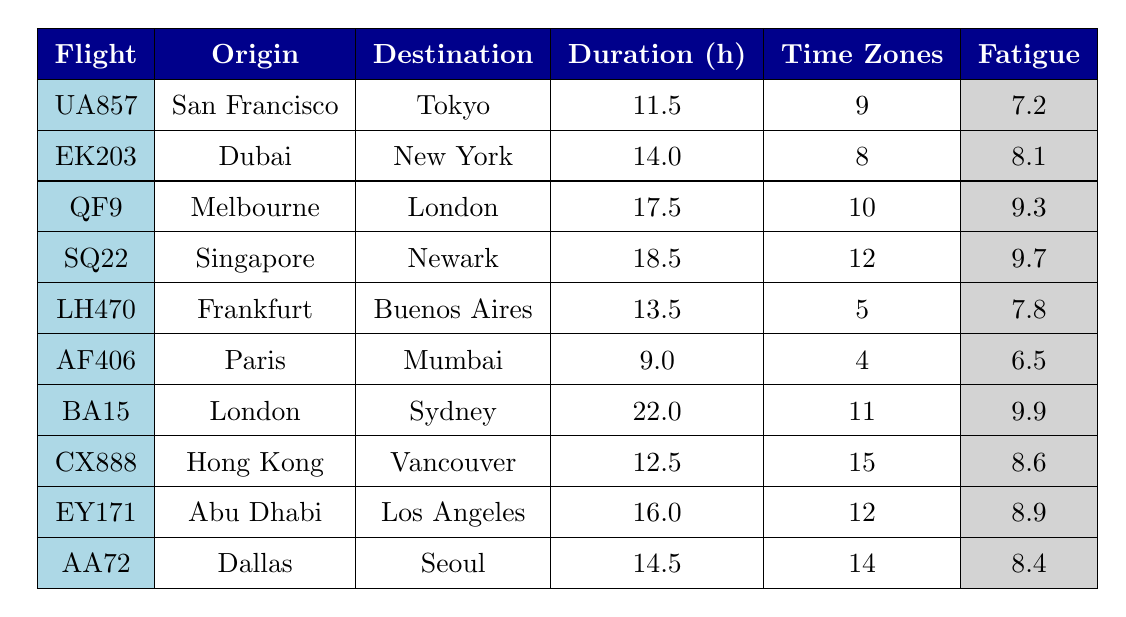What is the average fatigue level for flight EK203? Looking at the table, the average fatigue level is specified for each flight. For flight EK203, the average fatigue level is listed as 8.1.
Answer: 8.1 Which flight has the longest duration? By inspecting the duration column, we see that flight BA15 has the longest duration at 22 hours, compared to the other flights listed.
Answer: BA15 How many time zones does flight SQ22 cross? The table indicates the number of time zones crossed for each flight. Flight SQ22 crosses 12 time zones, according to the respective column.
Answer: 12 What is the fatigue level for the flight with the longest duration? From the analysis of the table, flight BA15 has the longest duration of 22 hours, and its average fatigue level is 9.9.
Answer: 9.9 Which flight has the highest average fatigue level? Examining the average fatigue levels in the table, flight BA15 has the highest average fatigue level at 9.9, more than any other flight.
Answer: BA15 Are there any flights that crossed fewer than 5 time zones? By reviewing the time zones crossed for each flight, we find that flights AF406 and LH470 crossed 4 and 5 time zones respectively. The answer is yes, as AF406 crosses fewer than 5.
Answer: Yes What is the average duration of flights that crossed 10 or more time zones? We identify the flights that crossed 10 or more time zones: QF9 (17.5 hours), SQ22 (18.5 hours), CX888 (12.5 hours), EY171 (16 hours), and AA72 (14.5 hours). Their total duration is (17.5 + 18.5 + 12.5 + 16 + 14.5) = 79 hours. With 5 flights, the average duration is 79/5 = 15.8 hours.
Answer: 15.8 What is the difference in average fatigue level between the shortest and longest flight durations? The shortest flight duration is AF406 at 9 hours with a fatigue level of 6.5. The longest is BA15 at 22 hours with a fatigue level of 9.9. The difference in fatigue is 9.9 - 6.5 = 3.4.
Answer: 3.4 How many flights have an average fatigue level of 8.5 or above? Upon reviewing the fatigue levels, the flights with fatigue levels of 8.5 or above are EK203 (8.1), QF9 (9.3), SQ22 (9.7), BA15 (9.9), CX888 (8.6), EY171 (8.9), and AA72 (8.4). This results in 5 flights meeting the criterion.
Answer: 5 